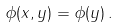<formula> <loc_0><loc_0><loc_500><loc_500>\phi ( x , y ) = \phi ( y ) \, .</formula> 